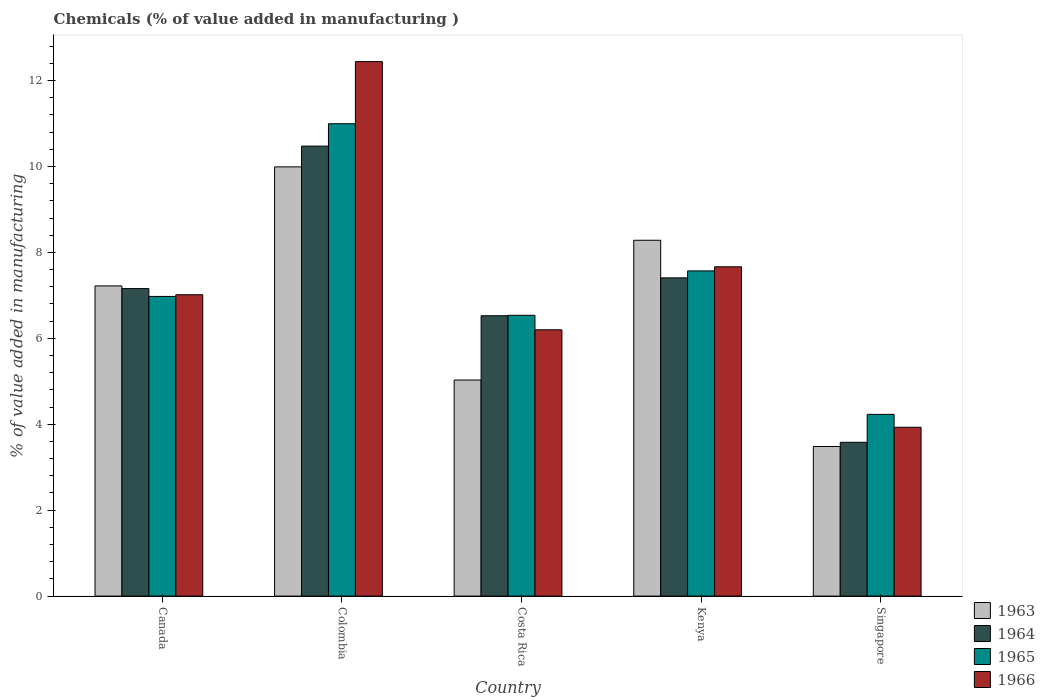Are the number of bars per tick equal to the number of legend labels?
Provide a short and direct response. Yes. How many bars are there on the 4th tick from the right?
Make the answer very short. 4. What is the label of the 4th group of bars from the left?
Give a very brief answer. Kenya. In how many cases, is the number of bars for a given country not equal to the number of legend labels?
Offer a terse response. 0. What is the value added in manufacturing chemicals in 1966 in Kenya?
Ensure brevity in your answer.  7.67. Across all countries, what is the maximum value added in manufacturing chemicals in 1964?
Offer a very short reply. 10.47. Across all countries, what is the minimum value added in manufacturing chemicals in 1965?
Your answer should be very brief. 4.23. In which country was the value added in manufacturing chemicals in 1964 minimum?
Give a very brief answer. Singapore. What is the total value added in manufacturing chemicals in 1966 in the graph?
Provide a succinct answer. 37.25. What is the difference between the value added in manufacturing chemicals in 1966 in Costa Rica and that in Singapore?
Offer a terse response. 2.27. What is the difference between the value added in manufacturing chemicals in 1965 in Canada and the value added in manufacturing chemicals in 1966 in Kenya?
Ensure brevity in your answer.  -0.69. What is the average value added in manufacturing chemicals in 1964 per country?
Your response must be concise. 7.03. What is the difference between the value added in manufacturing chemicals of/in 1964 and value added in manufacturing chemicals of/in 1966 in Costa Rica?
Ensure brevity in your answer.  0.33. In how many countries, is the value added in manufacturing chemicals in 1964 greater than 4.4 %?
Offer a very short reply. 4. What is the ratio of the value added in manufacturing chemicals in 1963 in Costa Rica to that in Kenya?
Your response must be concise. 0.61. Is the difference between the value added in manufacturing chemicals in 1964 in Canada and Singapore greater than the difference between the value added in manufacturing chemicals in 1966 in Canada and Singapore?
Provide a succinct answer. Yes. What is the difference between the highest and the second highest value added in manufacturing chemicals in 1963?
Offer a terse response. -1.71. What is the difference between the highest and the lowest value added in manufacturing chemicals in 1966?
Your response must be concise. 8.51. In how many countries, is the value added in manufacturing chemicals in 1965 greater than the average value added in manufacturing chemicals in 1965 taken over all countries?
Offer a terse response. 2. What does the 4th bar from the left in Canada represents?
Keep it short and to the point. 1966. Is it the case that in every country, the sum of the value added in manufacturing chemicals in 1966 and value added in manufacturing chemicals in 1964 is greater than the value added in manufacturing chemicals in 1965?
Give a very brief answer. Yes. Are all the bars in the graph horizontal?
Provide a short and direct response. No. How many countries are there in the graph?
Make the answer very short. 5. What is the difference between two consecutive major ticks on the Y-axis?
Give a very brief answer. 2. Where does the legend appear in the graph?
Provide a short and direct response. Bottom right. How many legend labels are there?
Your answer should be very brief. 4. How are the legend labels stacked?
Keep it short and to the point. Vertical. What is the title of the graph?
Keep it short and to the point. Chemicals (% of value added in manufacturing ). Does "1984" appear as one of the legend labels in the graph?
Offer a very short reply. No. What is the label or title of the Y-axis?
Ensure brevity in your answer.  % of value added in manufacturing. What is the % of value added in manufacturing of 1963 in Canada?
Your response must be concise. 7.22. What is the % of value added in manufacturing in 1964 in Canada?
Make the answer very short. 7.16. What is the % of value added in manufacturing in 1965 in Canada?
Offer a terse response. 6.98. What is the % of value added in manufacturing of 1966 in Canada?
Your answer should be very brief. 7.01. What is the % of value added in manufacturing in 1963 in Colombia?
Your answer should be compact. 9.99. What is the % of value added in manufacturing in 1964 in Colombia?
Keep it short and to the point. 10.47. What is the % of value added in manufacturing in 1965 in Colombia?
Keep it short and to the point. 10.99. What is the % of value added in manufacturing of 1966 in Colombia?
Make the answer very short. 12.44. What is the % of value added in manufacturing of 1963 in Costa Rica?
Your response must be concise. 5.03. What is the % of value added in manufacturing in 1964 in Costa Rica?
Ensure brevity in your answer.  6.53. What is the % of value added in manufacturing of 1965 in Costa Rica?
Ensure brevity in your answer.  6.54. What is the % of value added in manufacturing in 1966 in Costa Rica?
Ensure brevity in your answer.  6.2. What is the % of value added in manufacturing in 1963 in Kenya?
Give a very brief answer. 8.28. What is the % of value added in manufacturing of 1964 in Kenya?
Give a very brief answer. 7.41. What is the % of value added in manufacturing of 1965 in Kenya?
Offer a terse response. 7.57. What is the % of value added in manufacturing of 1966 in Kenya?
Provide a short and direct response. 7.67. What is the % of value added in manufacturing of 1963 in Singapore?
Keep it short and to the point. 3.48. What is the % of value added in manufacturing of 1964 in Singapore?
Your answer should be compact. 3.58. What is the % of value added in manufacturing of 1965 in Singapore?
Keep it short and to the point. 4.23. What is the % of value added in manufacturing of 1966 in Singapore?
Offer a terse response. 3.93. Across all countries, what is the maximum % of value added in manufacturing of 1963?
Make the answer very short. 9.99. Across all countries, what is the maximum % of value added in manufacturing of 1964?
Ensure brevity in your answer.  10.47. Across all countries, what is the maximum % of value added in manufacturing of 1965?
Your response must be concise. 10.99. Across all countries, what is the maximum % of value added in manufacturing of 1966?
Keep it short and to the point. 12.44. Across all countries, what is the minimum % of value added in manufacturing in 1963?
Keep it short and to the point. 3.48. Across all countries, what is the minimum % of value added in manufacturing of 1964?
Your response must be concise. 3.58. Across all countries, what is the minimum % of value added in manufacturing of 1965?
Keep it short and to the point. 4.23. Across all countries, what is the minimum % of value added in manufacturing in 1966?
Keep it short and to the point. 3.93. What is the total % of value added in manufacturing of 1963 in the graph?
Your response must be concise. 34.01. What is the total % of value added in manufacturing in 1964 in the graph?
Your response must be concise. 35.15. What is the total % of value added in manufacturing of 1965 in the graph?
Give a very brief answer. 36.31. What is the total % of value added in manufacturing in 1966 in the graph?
Make the answer very short. 37.25. What is the difference between the % of value added in manufacturing of 1963 in Canada and that in Colombia?
Ensure brevity in your answer.  -2.77. What is the difference between the % of value added in manufacturing of 1964 in Canada and that in Colombia?
Your answer should be very brief. -3.32. What is the difference between the % of value added in manufacturing of 1965 in Canada and that in Colombia?
Your answer should be compact. -4.02. What is the difference between the % of value added in manufacturing in 1966 in Canada and that in Colombia?
Provide a succinct answer. -5.43. What is the difference between the % of value added in manufacturing of 1963 in Canada and that in Costa Rica?
Ensure brevity in your answer.  2.19. What is the difference between the % of value added in manufacturing in 1964 in Canada and that in Costa Rica?
Offer a terse response. 0.63. What is the difference between the % of value added in manufacturing in 1965 in Canada and that in Costa Rica?
Your answer should be compact. 0.44. What is the difference between the % of value added in manufacturing of 1966 in Canada and that in Costa Rica?
Offer a terse response. 0.82. What is the difference between the % of value added in manufacturing of 1963 in Canada and that in Kenya?
Offer a very short reply. -1.06. What is the difference between the % of value added in manufacturing of 1964 in Canada and that in Kenya?
Your answer should be very brief. -0.25. What is the difference between the % of value added in manufacturing in 1965 in Canada and that in Kenya?
Your answer should be compact. -0.59. What is the difference between the % of value added in manufacturing in 1966 in Canada and that in Kenya?
Offer a terse response. -0.65. What is the difference between the % of value added in manufacturing in 1963 in Canada and that in Singapore?
Your response must be concise. 3.74. What is the difference between the % of value added in manufacturing in 1964 in Canada and that in Singapore?
Your answer should be very brief. 3.58. What is the difference between the % of value added in manufacturing in 1965 in Canada and that in Singapore?
Your answer should be compact. 2.75. What is the difference between the % of value added in manufacturing of 1966 in Canada and that in Singapore?
Ensure brevity in your answer.  3.08. What is the difference between the % of value added in manufacturing in 1963 in Colombia and that in Costa Rica?
Offer a terse response. 4.96. What is the difference between the % of value added in manufacturing of 1964 in Colombia and that in Costa Rica?
Your answer should be very brief. 3.95. What is the difference between the % of value added in manufacturing of 1965 in Colombia and that in Costa Rica?
Your answer should be very brief. 4.46. What is the difference between the % of value added in manufacturing of 1966 in Colombia and that in Costa Rica?
Your answer should be very brief. 6.24. What is the difference between the % of value added in manufacturing in 1963 in Colombia and that in Kenya?
Your answer should be compact. 1.71. What is the difference between the % of value added in manufacturing in 1964 in Colombia and that in Kenya?
Keep it short and to the point. 3.07. What is the difference between the % of value added in manufacturing of 1965 in Colombia and that in Kenya?
Keep it short and to the point. 3.43. What is the difference between the % of value added in manufacturing of 1966 in Colombia and that in Kenya?
Provide a short and direct response. 4.78. What is the difference between the % of value added in manufacturing of 1963 in Colombia and that in Singapore?
Make the answer very short. 6.51. What is the difference between the % of value added in manufacturing in 1964 in Colombia and that in Singapore?
Ensure brevity in your answer.  6.89. What is the difference between the % of value added in manufacturing of 1965 in Colombia and that in Singapore?
Offer a terse response. 6.76. What is the difference between the % of value added in manufacturing in 1966 in Colombia and that in Singapore?
Make the answer very short. 8.51. What is the difference between the % of value added in manufacturing in 1963 in Costa Rica and that in Kenya?
Make the answer very short. -3.25. What is the difference between the % of value added in manufacturing of 1964 in Costa Rica and that in Kenya?
Your answer should be very brief. -0.88. What is the difference between the % of value added in manufacturing in 1965 in Costa Rica and that in Kenya?
Your answer should be compact. -1.03. What is the difference between the % of value added in manufacturing of 1966 in Costa Rica and that in Kenya?
Your answer should be compact. -1.47. What is the difference between the % of value added in manufacturing in 1963 in Costa Rica and that in Singapore?
Provide a succinct answer. 1.55. What is the difference between the % of value added in manufacturing in 1964 in Costa Rica and that in Singapore?
Provide a succinct answer. 2.95. What is the difference between the % of value added in manufacturing of 1965 in Costa Rica and that in Singapore?
Your answer should be compact. 2.31. What is the difference between the % of value added in manufacturing of 1966 in Costa Rica and that in Singapore?
Offer a very short reply. 2.27. What is the difference between the % of value added in manufacturing in 1963 in Kenya and that in Singapore?
Give a very brief answer. 4.8. What is the difference between the % of value added in manufacturing in 1964 in Kenya and that in Singapore?
Your answer should be compact. 3.83. What is the difference between the % of value added in manufacturing in 1965 in Kenya and that in Singapore?
Your answer should be compact. 3.34. What is the difference between the % of value added in manufacturing in 1966 in Kenya and that in Singapore?
Ensure brevity in your answer.  3.74. What is the difference between the % of value added in manufacturing in 1963 in Canada and the % of value added in manufacturing in 1964 in Colombia?
Ensure brevity in your answer.  -3.25. What is the difference between the % of value added in manufacturing of 1963 in Canada and the % of value added in manufacturing of 1965 in Colombia?
Keep it short and to the point. -3.77. What is the difference between the % of value added in manufacturing of 1963 in Canada and the % of value added in manufacturing of 1966 in Colombia?
Make the answer very short. -5.22. What is the difference between the % of value added in manufacturing of 1964 in Canada and the % of value added in manufacturing of 1965 in Colombia?
Offer a terse response. -3.84. What is the difference between the % of value added in manufacturing of 1964 in Canada and the % of value added in manufacturing of 1966 in Colombia?
Your answer should be compact. -5.28. What is the difference between the % of value added in manufacturing in 1965 in Canada and the % of value added in manufacturing in 1966 in Colombia?
Offer a terse response. -5.47. What is the difference between the % of value added in manufacturing of 1963 in Canada and the % of value added in manufacturing of 1964 in Costa Rica?
Give a very brief answer. 0.69. What is the difference between the % of value added in manufacturing in 1963 in Canada and the % of value added in manufacturing in 1965 in Costa Rica?
Keep it short and to the point. 0.68. What is the difference between the % of value added in manufacturing in 1963 in Canada and the % of value added in manufacturing in 1966 in Costa Rica?
Your answer should be very brief. 1.02. What is the difference between the % of value added in manufacturing in 1964 in Canada and the % of value added in manufacturing in 1965 in Costa Rica?
Give a very brief answer. 0.62. What is the difference between the % of value added in manufacturing in 1964 in Canada and the % of value added in manufacturing in 1966 in Costa Rica?
Give a very brief answer. 0.96. What is the difference between the % of value added in manufacturing of 1965 in Canada and the % of value added in manufacturing of 1966 in Costa Rica?
Your answer should be compact. 0.78. What is the difference between the % of value added in manufacturing in 1963 in Canada and the % of value added in manufacturing in 1964 in Kenya?
Offer a very short reply. -0.19. What is the difference between the % of value added in manufacturing in 1963 in Canada and the % of value added in manufacturing in 1965 in Kenya?
Ensure brevity in your answer.  -0.35. What is the difference between the % of value added in manufacturing in 1963 in Canada and the % of value added in manufacturing in 1966 in Kenya?
Give a very brief answer. -0.44. What is the difference between the % of value added in manufacturing of 1964 in Canada and the % of value added in manufacturing of 1965 in Kenya?
Provide a short and direct response. -0.41. What is the difference between the % of value added in manufacturing of 1964 in Canada and the % of value added in manufacturing of 1966 in Kenya?
Provide a succinct answer. -0.51. What is the difference between the % of value added in manufacturing in 1965 in Canada and the % of value added in manufacturing in 1966 in Kenya?
Provide a succinct answer. -0.69. What is the difference between the % of value added in manufacturing in 1963 in Canada and the % of value added in manufacturing in 1964 in Singapore?
Your answer should be very brief. 3.64. What is the difference between the % of value added in manufacturing of 1963 in Canada and the % of value added in manufacturing of 1965 in Singapore?
Ensure brevity in your answer.  2.99. What is the difference between the % of value added in manufacturing in 1963 in Canada and the % of value added in manufacturing in 1966 in Singapore?
Keep it short and to the point. 3.29. What is the difference between the % of value added in manufacturing of 1964 in Canada and the % of value added in manufacturing of 1965 in Singapore?
Make the answer very short. 2.93. What is the difference between the % of value added in manufacturing of 1964 in Canada and the % of value added in manufacturing of 1966 in Singapore?
Keep it short and to the point. 3.23. What is the difference between the % of value added in manufacturing in 1965 in Canada and the % of value added in manufacturing in 1966 in Singapore?
Offer a very short reply. 3.05. What is the difference between the % of value added in manufacturing in 1963 in Colombia and the % of value added in manufacturing in 1964 in Costa Rica?
Offer a very short reply. 3.47. What is the difference between the % of value added in manufacturing in 1963 in Colombia and the % of value added in manufacturing in 1965 in Costa Rica?
Ensure brevity in your answer.  3.46. What is the difference between the % of value added in manufacturing of 1963 in Colombia and the % of value added in manufacturing of 1966 in Costa Rica?
Ensure brevity in your answer.  3.79. What is the difference between the % of value added in manufacturing of 1964 in Colombia and the % of value added in manufacturing of 1965 in Costa Rica?
Give a very brief answer. 3.94. What is the difference between the % of value added in manufacturing of 1964 in Colombia and the % of value added in manufacturing of 1966 in Costa Rica?
Your response must be concise. 4.28. What is the difference between the % of value added in manufacturing of 1965 in Colombia and the % of value added in manufacturing of 1966 in Costa Rica?
Ensure brevity in your answer.  4.8. What is the difference between the % of value added in manufacturing in 1963 in Colombia and the % of value added in manufacturing in 1964 in Kenya?
Offer a very short reply. 2.58. What is the difference between the % of value added in manufacturing in 1963 in Colombia and the % of value added in manufacturing in 1965 in Kenya?
Keep it short and to the point. 2.42. What is the difference between the % of value added in manufacturing in 1963 in Colombia and the % of value added in manufacturing in 1966 in Kenya?
Give a very brief answer. 2.33. What is the difference between the % of value added in manufacturing of 1964 in Colombia and the % of value added in manufacturing of 1965 in Kenya?
Your answer should be compact. 2.9. What is the difference between the % of value added in manufacturing of 1964 in Colombia and the % of value added in manufacturing of 1966 in Kenya?
Your response must be concise. 2.81. What is the difference between the % of value added in manufacturing of 1965 in Colombia and the % of value added in manufacturing of 1966 in Kenya?
Offer a very short reply. 3.33. What is the difference between the % of value added in manufacturing in 1963 in Colombia and the % of value added in manufacturing in 1964 in Singapore?
Give a very brief answer. 6.41. What is the difference between the % of value added in manufacturing in 1963 in Colombia and the % of value added in manufacturing in 1965 in Singapore?
Give a very brief answer. 5.76. What is the difference between the % of value added in manufacturing in 1963 in Colombia and the % of value added in manufacturing in 1966 in Singapore?
Your response must be concise. 6.06. What is the difference between the % of value added in manufacturing in 1964 in Colombia and the % of value added in manufacturing in 1965 in Singapore?
Give a very brief answer. 6.24. What is the difference between the % of value added in manufacturing of 1964 in Colombia and the % of value added in manufacturing of 1966 in Singapore?
Provide a short and direct response. 6.54. What is the difference between the % of value added in manufacturing of 1965 in Colombia and the % of value added in manufacturing of 1966 in Singapore?
Keep it short and to the point. 7.07. What is the difference between the % of value added in manufacturing of 1963 in Costa Rica and the % of value added in manufacturing of 1964 in Kenya?
Provide a succinct answer. -2.38. What is the difference between the % of value added in manufacturing in 1963 in Costa Rica and the % of value added in manufacturing in 1965 in Kenya?
Your response must be concise. -2.54. What is the difference between the % of value added in manufacturing in 1963 in Costa Rica and the % of value added in manufacturing in 1966 in Kenya?
Give a very brief answer. -2.64. What is the difference between the % of value added in manufacturing of 1964 in Costa Rica and the % of value added in manufacturing of 1965 in Kenya?
Your answer should be very brief. -1.04. What is the difference between the % of value added in manufacturing in 1964 in Costa Rica and the % of value added in manufacturing in 1966 in Kenya?
Provide a succinct answer. -1.14. What is the difference between the % of value added in manufacturing of 1965 in Costa Rica and the % of value added in manufacturing of 1966 in Kenya?
Offer a terse response. -1.13. What is the difference between the % of value added in manufacturing of 1963 in Costa Rica and the % of value added in manufacturing of 1964 in Singapore?
Keep it short and to the point. 1.45. What is the difference between the % of value added in manufacturing in 1963 in Costa Rica and the % of value added in manufacturing in 1965 in Singapore?
Give a very brief answer. 0.8. What is the difference between the % of value added in manufacturing of 1963 in Costa Rica and the % of value added in manufacturing of 1966 in Singapore?
Your answer should be very brief. 1.1. What is the difference between the % of value added in manufacturing of 1964 in Costa Rica and the % of value added in manufacturing of 1965 in Singapore?
Ensure brevity in your answer.  2.3. What is the difference between the % of value added in manufacturing of 1964 in Costa Rica and the % of value added in manufacturing of 1966 in Singapore?
Your answer should be compact. 2.6. What is the difference between the % of value added in manufacturing in 1965 in Costa Rica and the % of value added in manufacturing in 1966 in Singapore?
Offer a terse response. 2.61. What is the difference between the % of value added in manufacturing in 1963 in Kenya and the % of value added in manufacturing in 1964 in Singapore?
Your answer should be very brief. 4.7. What is the difference between the % of value added in manufacturing in 1963 in Kenya and the % of value added in manufacturing in 1965 in Singapore?
Keep it short and to the point. 4.05. What is the difference between the % of value added in manufacturing in 1963 in Kenya and the % of value added in manufacturing in 1966 in Singapore?
Offer a very short reply. 4.35. What is the difference between the % of value added in manufacturing of 1964 in Kenya and the % of value added in manufacturing of 1965 in Singapore?
Your response must be concise. 3.18. What is the difference between the % of value added in manufacturing of 1964 in Kenya and the % of value added in manufacturing of 1966 in Singapore?
Your response must be concise. 3.48. What is the difference between the % of value added in manufacturing of 1965 in Kenya and the % of value added in manufacturing of 1966 in Singapore?
Give a very brief answer. 3.64. What is the average % of value added in manufacturing of 1963 per country?
Give a very brief answer. 6.8. What is the average % of value added in manufacturing of 1964 per country?
Keep it short and to the point. 7.03. What is the average % of value added in manufacturing of 1965 per country?
Provide a succinct answer. 7.26. What is the average % of value added in manufacturing in 1966 per country?
Offer a terse response. 7.45. What is the difference between the % of value added in manufacturing in 1963 and % of value added in manufacturing in 1964 in Canada?
Offer a very short reply. 0.06. What is the difference between the % of value added in manufacturing in 1963 and % of value added in manufacturing in 1965 in Canada?
Give a very brief answer. 0.25. What is the difference between the % of value added in manufacturing in 1963 and % of value added in manufacturing in 1966 in Canada?
Ensure brevity in your answer.  0.21. What is the difference between the % of value added in manufacturing in 1964 and % of value added in manufacturing in 1965 in Canada?
Provide a succinct answer. 0.18. What is the difference between the % of value added in manufacturing of 1964 and % of value added in manufacturing of 1966 in Canada?
Your response must be concise. 0.14. What is the difference between the % of value added in manufacturing of 1965 and % of value added in manufacturing of 1966 in Canada?
Your answer should be very brief. -0.04. What is the difference between the % of value added in manufacturing in 1963 and % of value added in manufacturing in 1964 in Colombia?
Give a very brief answer. -0.48. What is the difference between the % of value added in manufacturing in 1963 and % of value added in manufacturing in 1965 in Colombia?
Make the answer very short. -1. What is the difference between the % of value added in manufacturing in 1963 and % of value added in manufacturing in 1966 in Colombia?
Offer a terse response. -2.45. What is the difference between the % of value added in manufacturing in 1964 and % of value added in manufacturing in 1965 in Colombia?
Offer a terse response. -0.52. What is the difference between the % of value added in manufacturing of 1964 and % of value added in manufacturing of 1966 in Colombia?
Make the answer very short. -1.97. What is the difference between the % of value added in manufacturing of 1965 and % of value added in manufacturing of 1966 in Colombia?
Make the answer very short. -1.45. What is the difference between the % of value added in manufacturing of 1963 and % of value added in manufacturing of 1964 in Costa Rica?
Provide a succinct answer. -1.5. What is the difference between the % of value added in manufacturing in 1963 and % of value added in manufacturing in 1965 in Costa Rica?
Ensure brevity in your answer.  -1.51. What is the difference between the % of value added in manufacturing in 1963 and % of value added in manufacturing in 1966 in Costa Rica?
Offer a terse response. -1.17. What is the difference between the % of value added in manufacturing of 1964 and % of value added in manufacturing of 1965 in Costa Rica?
Offer a very short reply. -0.01. What is the difference between the % of value added in manufacturing in 1964 and % of value added in manufacturing in 1966 in Costa Rica?
Provide a succinct answer. 0.33. What is the difference between the % of value added in manufacturing in 1965 and % of value added in manufacturing in 1966 in Costa Rica?
Keep it short and to the point. 0.34. What is the difference between the % of value added in manufacturing of 1963 and % of value added in manufacturing of 1964 in Kenya?
Offer a terse response. 0.87. What is the difference between the % of value added in manufacturing of 1963 and % of value added in manufacturing of 1965 in Kenya?
Offer a terse response. 0.71. What is the difference between the % of value added in manufacturing in 1963 and % of value added in manufacturing in 1966 in Kenya?
Offer a terse response. 0.62. What is the difference between the % of value added in manufacturing in 1964 and % of value added in manufacturing in 1965 in Kenya?
Provide a succinct answer. -0.16. What is the difference between the % of value added in manufacturing of 1964 and % of value added in manufacturing of 1966 in Kenya?
Keep it short and to the point. -0.26. What is the difference between the % of value added in manufacturing in 1965 and % of value added in manufacturing in 1966 in Kenya?
Your answer should be very brief. -0.1. What is the difference between the % of value added in manufacturing of 1963 and % of value added in manufacturing of 1964 in Singapore?
Offer a very short reply. -0.1. What is the difference between the % of value added in manufacturing of 1963 and % of value added in manufacturing of 1965 in Singapore?
Provide a short and direct response. -0.75. What is the difference between the % of value added in manufacturing of 1963 and % of value added in manufacturing of 1966 in Singapore?
Offer a very short reply. -0.45. What is the difference between the % of value added in manufacturing in 1964 and % of value added in manufacturing in 1965 in Singapore?
Keep it short and to the point. -0.65. What is the difference between the % of value added in manufacturing in 1964 and % of value added in manufacturing in 1966 in Singapore?
Offer a very short reply. -0.35. What is the difference between the % of value added in manufacturing of 1965 and % of value added in manufacturing of 1966 in Singapore?
Your response must be concise. 0.3. What is the ratio of the % of value added in manufacturing of 1963 in Canada to that in Colombia?
Provide a succinct answer. 0.72. What is the ratio of the % of value added in manufacturing of 1964 in Canada to that in Colombia?
Keep it short and to the point. 0.68. What is the ratio of the % of value added in manufacturing of 1965 in Canada to that in Colombia?
Offer a terse response. 0.63. What is the ratio of the % of value added in manufacturing in 1966 in Canada to that in Colombia?
Keep it short and to the point. 0.56. What is the ratio of the % of value added in manufacturing in 1963 in Canada to that in Costa Rica?
Provide a succinct answer. 1.44. What is the ratio of the % of value added in manufacturing of 1964 in Canada to that in Costa Rica?
Offer a very short reply. 1.1. What is the ratio of the % of value added in manufacturing in 1965 in Canada to that in Costa Rica?
Ensure brevity in your answer.  1.07. What is the ratio of the % of value added in manufacturing in 1966 in Canada to that in Costa Rica?
Offer a terse response. 1.13. What is the ratio of the % of value added in manufacturing of 1963 in Canada to that in Kenya?
Your answer should be compact. 0.87. What is the ratio of the % of value added in manufacturing of 1964 in Canada to that in Kenya?
Your answer should be very brief. 0.97. What is the ratio of the % of value added in manufacturing in 1965 in Canada to that in Kenya?
Your answer should be very brief. 0.92. What is the ratio of the % of value added in manufacturing in 1966 in Canada to that in Kenya?
Offer a very short reply. 0.92. What is the ratio of the % of value added in manufacturing in 1963 in Canada to that in Singapore?
Your answer should be compact. 2.07. What is the ratio of the % of value added in manufacturing in 1964 in Canada to that in Singapore?
Offer a terse response. 2. What is the ratio of the % of value added in manufacturing of 1965 in Canada to that in Singapore?
Offer a very short reply. 1.65. What is the ratio of the % of value added in manufacturing of 1966 in Canada to that in Singapore?
Make the answer very short. 1.78. What is the ratio of the % of value added in manufacturing in 1963 in Colombia to that in Costa Rica?
Give a very brief answer. 1.99. What is the ratio of the % of value added in manufacturing of 1964 in Colombia to that in Costa Rica?
Your answer should be very brief. 1.61. What is the ratio of the % of value added in manufacturing of 1965 in Colombia to that in Costa Rica?
Keep it short and to the point. 1.68. What is the ratio of the % of value added in manufacturing of 1966 in Colombia to that in Costa Rica?
Keep it short and to the point. 2.01. What is the ratio of the % of value added in manufacturing in 1963 in Colombia to that in Kenya?
Provide a short and direct response. 1.21. What is the ratio of the % of value added in manufacturing in 1964 in Colombia to that in Kenya?
Offer a very short reply. 1.41. What is the ratio of the % of value added in manufacturing in 1965 in Colombia to that in Kenya?
Provide a succinct answer. 1.45. What is the ratio of the % of value added in manufacturing in 1966 in Colombia to that in Kenya?
Your answer should be very brief. 1.62. What is the ratio of the % of value added in manufacturing in 1963 in Colombia to that in Singapore?
Keep it short and to the point. 2.87. What is the ratio of the % of value added in manufacturing of 1964 in Colombia to that in Singapore?
Your answer should be very brief. 2.93. What is the ratio of the % of value added in manufacturing of 1965 in Colombia to that in Singapore?
Give a very brief answer. 2.6. What is the ratio of the % of value added in manufacturing in 1966 in Colombia to that in Singapore?
Offer a terse response. 3.17. What is the ratio of the % of value added in manufacturing in 1963 in Costa Rica to that in Kenya?
Ensure brevity in your answer.  0.61. What is the ratio of the % of value added in manufacturing in 1964 in Costa Rica to that in Kenya?
Ensure brevity in your answer.  0.88. What is the ratio of the % of value added in manufacturing in 1965 in Costa Rica to that in Kenya?
Your answer should be compact. 0.86. What is the ratio of the % of value added in manufacturing in 1966 in Costa Rica to that in Kenya?
Your response must be concise. 0.81. What is the ratio of the % of value added in manufacturing of 1963 in Costa Rica to that in Singapore?
Offer a terse response. 1.44. What is the ratio of the % of value added in manufacturing in 1964 in Costa Rica to that in Singapore?
Make the answer very short. 1.82. What is the ratio of the % of value added in manufacturing of 1965 in Costa Rica to that in Singapore?
Make the answer very short. 1.55. What is the ratio of the % of value added in manufacturing in 1966 in Costa Rica to that in Singapore?
Your answer should be compact. 1.58. What is the ratio of the % of value added in manufacturing in 1963 in Kenya to that in Singapore?
Provide a short and direct response. 2.38. What is the ratio of the % of value added in manufacturing of 1964 in Kenya to that in Singapore?
Make the answer very short. 2.07. What is the ratio of the % of value added in manufacturing in 1965 in Kenya to that in Singapore?
Provide a succinct answer. 1.79. What is the ratio of the % of value added in manufacturing in 1966 in Kenya to that in Singapore?
Offer a terse response. 1.95. What is the difference between the highest and the second highest % of value added in manufacturing of 1963?
Offer a terse response. 1.71. What is the difference between the highest and the second highest % of value added in manufacturing in 1964?
Keep it short and to the point. 3.07. What is the difference between the highest and the second highest % of value added in manufacturing in 1965?
Your answer should be very brief. 3.43. What is the difference between the highest and the second highest % of value added in manufacturing in 1966?
Give a very brief answer. 4.78. What is the difference between the highest and the lowest % of value added in manufacturing of 1963?
Offer a very short reply. 6.51. What is the difference between the highest and the lowest % of value added in manufacturing of 1964?
Keep it short and to the point. 6.89. What is the difference between the highest and the lowest % of value added in manufacturing in 1965?
Provide a succinct answer. 6.76. What is the difference between the highest and the lowest % of value added in manufacturing in 1966?
Offer a very short reply. 8.51. 